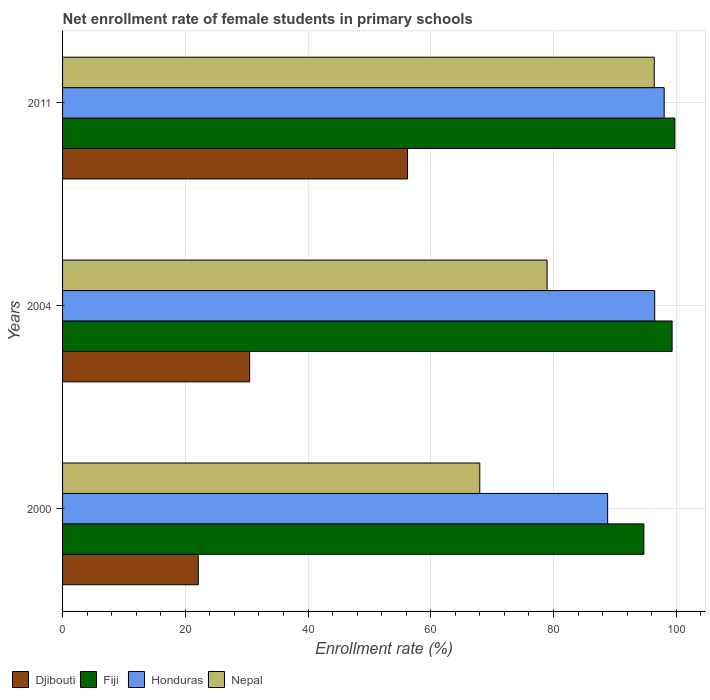How many groups of bars are there?
Give a very brief answer. 3. Are the number of bars per tick equal to the number of legend labels?
Your answer should be compact. Yes. Are the number of bars on each tick of the Y-axis equal?
Offer a terse response. Yes. How many bars are there on the 1st tick from the top?
Keep it short and to the point. 4. How many bars are there on the 3rd tick from the bottom?
Give a very brief answer. 4. What is the net enrollment rate of female students in primary schools in Djibouti in 2000?
Offer a very short reply. 22.11. Across all years, what is the maximum net enrollment rate of female students in primary schools in Djibouti?
Make the answer very short. 56.22. Across all years, what is the minimum net enrollment rate of female students in primary schools in Nepal?
Offer a very short reply. 67.99. In which year was the net enrollment rate of female students in primary schools in Fiji maximum?
Make the answer very short. 2011. In which year was the net enrollment rate of female students in primary schools in Fiji minimum?
Provide a succinct answer. 2000. What is the total net enrollment rate of female students in primary schools in Fiji in the graph?
Offer a terse response. 293.85. What is the difference between the net enrollment rate of female students in primary schools in Fiji in 2000 and that in 2004?
Your answer should be very brief. -4.6. What is the difference between the net enrollment rate of female students in primary schools in Nepal in 2004 and the net enrollment rate of female students in primary schools in Honduras in 2000?
Your response must be concise. -9.87. What is the average net enrollment rate of female students in primary schools in Honduras per year?
Provide a short and direct response. 94.45. In the year 2004, what is the difference between the net enrollment rate of female students in primary schools in Nepal and net enrollment rate of female students in primary schools in Djibouti?
Give a very brief answer. 48.47. In how many years, is the net enrollment rate of female students in primary schools in Nepal greater than 24 %?
Your answer should be compact. 3. What is the ratio of the net enrollment rate of female students in primary schools in Fiji in 2000 to that in 2004?
Provide a succinct answer. 0.95. Is the net enrollment rate of female students in primary schools in Honduras in 2000 less than that in 2004?
Keep it short and to the point. Yes. What is the difference between the highest and the second highest net enrollment rate of female students in primary schools in Nepal?
Give a very brief answer. 17.47. What is the difference between the highest and the lowest net enrollment rate of female students in primary schools in Djibouti?
Your answer should be compact. 34.1. What does the 3rd bar from the top in 2011 represents?
Your response must be concise. Fiji. What does the 2nd bar from the bottom in 2004 represents?
Give a very brief answer. Fiji. Is it the case that in every year, the sum of the net enrollment rate of female students in primary schools in Djibouti and net enrollment rate of female students in primary schools in Honduras is greater than the net enrollment rate of female students in primary schools in Fiji?
Your answer should be very brief. Yes. How many bars are there?
Your answer should be compact. 12. Are all the bars in the graph horizontal?
Give a very brief answer. Yes. How many years are there in the graph?
Give a very brief answer. 3. Are the values on the major ticks of X-axis written in scientific E-notation?
Provide a succinct answer. No. Does the graph contain any zero values?
Your response must be concise. No. Does the graph contain grids?
Your answer should be compact. Yes. Where does the legend appear in the graph?
Provide a short and direct response. Bottom left. How are the legend labels stacked?
Your answer should be very brief. Horizontal. What is the title of the graph?
Your answer should be compact. Net enrollment rate of female students in primary schools. Does "Togo" appear as one of the legend labels in the graph?
Your answer should be compact. No. What is the label or title of the X-axis?
Provide a succinct answer. Enrollment rate (%). What is the Enrollment rate (%) in Djibouti in 2000?
Ensure brevity in your answer.  22.11. What is the Enrollment rate (%) of Fiji in 2000?
Make the answer very short. 94.73. What is the Enrollment rate (%) of Honduras in 2000?
Your response must be concise. 88.83. What is the Enrollment rate (%) of Nepal in 2000?
Your answer should be very brief. 67.99. What is the Enrollment rate (%) of Djibouti in 2004?
Ensure brevity in your answer.  30.49. What is the Enrollment rate (%) of Fiji in 2004?
Your answer should be very brief. 99.33. What is the Enrollment rate (%) of Honduras in 2004?
Provide a succinct answer. 96.5. What is the Enrollment rate (%) in Nepal in 2004?
Give a very brief answer. 78.96. What is the Enrollment rate (%) in Djibouti in 2011?
Offer a terse response. 56.22. What is the Enrollment rate (%) of Fiji in 2011?
Make the answer very short. 99.78. What is the Enrollment rate (%) in Honduras in 2011?
Your answer should be compact. 98.04. What is the Enrollment rate (%) in Nepal in 2011?
Your response must be concise. 96.42. Across all years, what is the maximum Enrollment rate (%) in Djibouti?
Give a very brief answer. 56.22. Across all years, what is the maximum Enrollment rate (%) of Fiji?
Ensure brevity in your answer.  99.78. Across all years, what is the maximum Enrollment rate (%) in Honduras?
Keep it short and to the point. 98.04. Across all years, what is the maximum Enrollment rate (%) of Nepal?
Provide a succinct answer. 96.42. Across all years, what is the minimum Enrollment rate (%) in Djibouti?
Provide a short and direct response. 22.11. Across all years, what is the minimum Enrollment rate (%) of Fiji?
Offer a terse response. 94.73. Across all years, what is the minimum Enrollment rate (%) in Honduras?
Offer a very short reply. 88.83. Across all years, what is the minimum Enrollment rate (%) of Nepal?
Keep it short and to the point. 67.99. What is the total Enrollment rate (%) of Djibouti in the graph?
Offer a very short reply. 108.82. What is the total Enrollment rate (%) of Fiji in the graph?
Your answer should be very brief. 293.85. What is the total Enrollment rate (%) of Honduras in the graph?
Offer a very short reply. 283.36. What is the total Enrollment rate (%) in Nepal in the graph?
Offer a very short reply. 243.37. What is the difference between the Enrollment rate (%) in Djibouti in 2000 and that in 2004?
Your response must be concise. -8.37. What is the difference between the Enrollment rate (%) of Fiji in 2000 and that in 2004?
Your answer should be very brief. -4.6. What is the difference between the Enrollment rate (%) in Honduras in 2000 and that in 2004?
Provide a short and direct response. -7.67. What is the difference between the Enrollment rate (%) of Nepal in 2000 and that in 2004?
Give a very brief answer. -10.96. What is the difference between the Enrollment rate (%) of Djibouti in 2000 and that in 2011?
Make the answer very short. -34.1. What is the difference between the Enrollment rate (%) of Fiji in 2000 and that in 2011?
Your answer should be compact. -5.05. What is the difference between the Enrollment rate (%) in Honduras in 2000 and that in 2011?
Give a very brief answer. -9.22. What is the difference between the Enrollment rate (%) of Nepal in 2000 and that in 2011?
Offer a very short reply. -28.43. What is the difference between the Enrollment rate (%) of Djibouti in 2004 and that in 2011?
Your response must be concise. -25.73. What is the difference between the Enrollment rate (%) in Fiji in 2004 and that in 2011?
Provide a succinct answer. -0.45. What is the difference between the Enrollment rate (%) of Honduras in 2004 and that in 2011?
Ensure brevity in your answer.  -1.54. What is the difference between the Enrollment rate (%) of Nepal in 2004 and that in 2011?
Give a very brief answer. -17.46. What is the difference between the Enrollment rate (%) in Djibouti in 2000 and the Enrollment rate (%) in Fiji in 2004?
Offer a terse response. -77.22. What is the difference between the Enrollment rate (%) in Djibouti in 2000 and the Enrollment rate (%) in Honduras in 2004?
Give a very brief answer. -74.38. What is the difference between the Enrollment rate (%) in Djibouti in 2000 and the Enrollment rate (%) in Nepal in 2004?
Offer a very short reply. -56.84. What is the difference between the Enrollment rate (%) of Fiji in 2000 and the Enrollment rate (%) of Honduras in 2004?
Ensure brevity in your answer.  -1.76. What is the difference between the Enrollment rate (%) in Fiji in 2000 and the Enrollment rate (%) in Nepal in 2004?
Offer a very short reply. 15.78. What is the difference between the Enrollment rate (%) of Honduras in 2000 and the Enrollment rate (%) of Nepal in 2004?
Your response must be concise. 9.87. What is the difference between the Enrollment rate (%) of Djibouti in 2000 and the Enrollment rate (%) of Fiji in 2011?
Give a very brief answer. -77.67. What is the difference between the Enrollment rate (%) of Djibouti in 2000 and the Enrollment rate (%) of Honduras in 2011?
Your answer should be very brief. -75.93. What is the difference between the Enrollment rate (%) of Djibouti in 2000 and the Enrollment rate (%) of Nepal in 2011?
Provide a short and direct response. -74.31. What is the difference between the Enrollment rate (%) in Fiji in 2000 and the Enrollment rate (%) in Honduras in 2011?
Your answer should be compact. -3.31. What is the difference between the Enrollment rate (%) in Fiji in 2000 and the Enrollment rate (%) in Nepal in 2011?
Provide a succinct answer. -1.69. What is the difference between the Enrollment rate (%) in Honduras in 2000 and the Enrollment rate (%) in Nepal in 2011?
Ensure brevity in your answer.  -7.59. What is the difference between the Enrollment rate (%) in Djibouti in 2004 and the Enrollment rate (%) in Fiji in 2011?
Your response must be concise. -69.29. What is the difference between the Enrollment rate (%) of Djibouti in 2004 and the Enrollment rate (%) of Honduras in 2011?
Provide a succinct answer. -67.55. What is the difference between the Enrollment rate (%) of Djibouti in 2004 and the Enrollment rate (%) of Nepal in 2011?
Your answer should be compact. -65.93. What is the difference between the Enrollment rate (%) of Fiji in 2004 and the Enrollment rate (%) of Honduras in 2011?
Offer a terse response. 1.29. What is the difference between the Enrollment rate (%) of Fiji in 2004 and the Enrollment rate (%) of Nepal in 2011?
Your answer should be compact. 2.91. What is the difference between the Enrollment rate (%) of Honduras in 2004 and the Enrollment rate (%) of Nepal in 2011?
Your answer should be very brief. 0.08. What is the average Enrollment rate (%) of Djibouti per year?
Keep it short and to the point. 36.27. What is the average Enrollment rate (%) in Fiji per year?
Offer a very short reply. 97.95. What is the average Enrollment rate (%) in Honduras per year?
Ensure brevity in your answer.  94.45. What is the average Enrollment rate (%) of Nepal per year?
Offer a very short reply. 81.12. In the year 2000, what is the difference between the Enrollment rate (%) of Djibouti and Enrollment rate (%) of Fiji?
Offer a very short reply. -72.62. In the year 2000, what is the difference between the Enrollment rate (%) of Djibouti and Enrollment rate (%) of Honduras?
Your response must be concise. -66.71. In the year 2000, what is the difference between the Enrollment rate (%) of Djibouti and Enrollment rate (%) of Nepal?
Keep it short and to the point. -45.88. In the year 2000, what is the difference between the Enrollment rate (%) in Fiji and Enrollment rate (%) in Honduras?
Provide a succinct answer. 5.91. In the year 2000, what is the difference between the Enrollment rate (%) in Fiji and Enrollment rate (%) in Nepal?
Provide a succinct answer. 26.74. In the year 2000, what is the difference between the Enrollment rate (%) in Honduras and Enrollment rate (%) in Nepal?
Provide a succinct answer. 20.83. In the year 2004, what is the difference between the Enrollment rate (%) of Djibouti and Enrollment rate (%) of Fiji?
Give a very brief answer. -68.84. In the year 2004, what is the difference between the Enrollment rate (%) in Djibouti and Enrollment rate (%) in Honduras?
Ensure brevity in your answer.  -66.01. In the year 2004, what is the difference between the Enrollment rate (%) in Djibouti and Enrollment rate (%) in Nepal?
Your answer should be very brief. -48.47. In the year 2004, what is the difference between the Enrollment rate (%) of Fiji and Enrollment rate (%) of Honduras?
Provide a succinct answer. 2.84. In the year 2004, what is the difference between the Enrollment rate (%) of Fiji and Enrollment rate (%) of Nepal?
Make the answer very short. 20.38. In the year 2004, what is the difference between the Enrollment rate (%) in Honduras and Enrollment rate (%) in Nepal?
Provide a short and direct response. 17.54. In the year 2011, what is the difference between the Enrollment rate (%) in Djibouti and Enrollment rate (%) in Fiji?
Ensure brevity in your answer.  -43.57. In the year 2011, what is the difference between the Enrollment rate (%) in Djibouti and Enrollment rate (%) in Honduras?
Your answer should be compact. -41.83. In the year 2011, what is the difference between the Enrollment rate (%) of Djibouti and Enrollment rate (%) of Nepal?
Your response must be concise. -40.21. In the year 2011, what is the difference between the Enrollment rate (%) in Fiji and Enrollment rate (%) in Honduras?
Offer a very short reply. 1.74. In the year 2011, what is the difference between the Enrollment rate (%) of Fiji and Enrollment rate (%) of Nepal?
Ensure brevity in your answer.  3.36. In the year 2011, what is the difference between the Enrollment rate (%) of Honduras and Enrollment rate (%) of Nepal?
Give a very brief answer. 1.62. What is the ratio of the Enrollment rate (%) in Djibouti in 2000 to that in 2004?
Your answer should be compact. 0.73. What is the ratio of the Enrollment rate (%) of Fiji in 2000 to that in 2004?
Ensure brevity in your answer.  0.95. What is the ratio of the Enrollment rate (%) in Honduras in 2000 to that in 2004?
Your answer should be very brief. 0.92. What is the ratio of the Enrollment rate (%) in Nepal in 2000 to that in 2004?
Your answer should be compact. 0.86. What is the ratio of the Enrollment rate (%) of Djibouti in 2000 to that in 2011?
Your answer should be compact. 0.39. What is the ratio of the Enrollment rate (%) of Fiji in 2000 to that in 2011?
Ensure brevity in your answer.  0.95. What is the ratio of the Enrollment rate (%) of Honduras in 2000 to that in 2011?
Your answer should be compact. 0.91. What is the ratio of the Enrollment rate (%) of Nepal in 2000 to that in 2011?
Provide a short and direct response. 0.71. What is the ratio of the Enrollment rate (%) of Djibouti in 2004 to that in 2011?
Offer a very short reply. 0.54. What is the ratio of the Enrollment rate (%) of Fiji in 2004 to that in 2011?
Keep it short and to the point. 1. What is the ratio of the Enrollment rate (%) of Honduras in 2004 to that in 2011?
Provide a short and direct response. 0.98. What is the ratio of the Enrollment rate (%) of Nepal in 2004 to that in 2011?
Make the answer very short. 0.82. What is the difference between the highest and the second highest Enrollment rate (%) of Djibouti?
Ensure brevity in your answer.  25.73. What is the difference between the highest and the second highest Enrollment rate (%) in Fiji?
Your answer should be compact. 0.45. What is the difference between the highest and the second highest Enrollment rate (%) in Honduras?
Provide a short and direct response. 1.54. What is the difference between the highest and the second highest Enrollment rate (%) in Nepal?
Offer a very short reply. 17.46. What is the difference between the highest and the lowest Enrollment rate (%) in Djibouti?
Your answer should be compact. 34.1. What is the difference between the highest and the lowest Enrollment rate (%) in Fiji?
Provide a short and direct response. 5.05. What is the difference between the highest and the lowest Enrollment rate (%) in Honduras?
Make the answer very short. 9.22. What is the difference between the highest and the lowest Enrollment rate (%) in Nepal?
Make the answer very short. 28.43. 